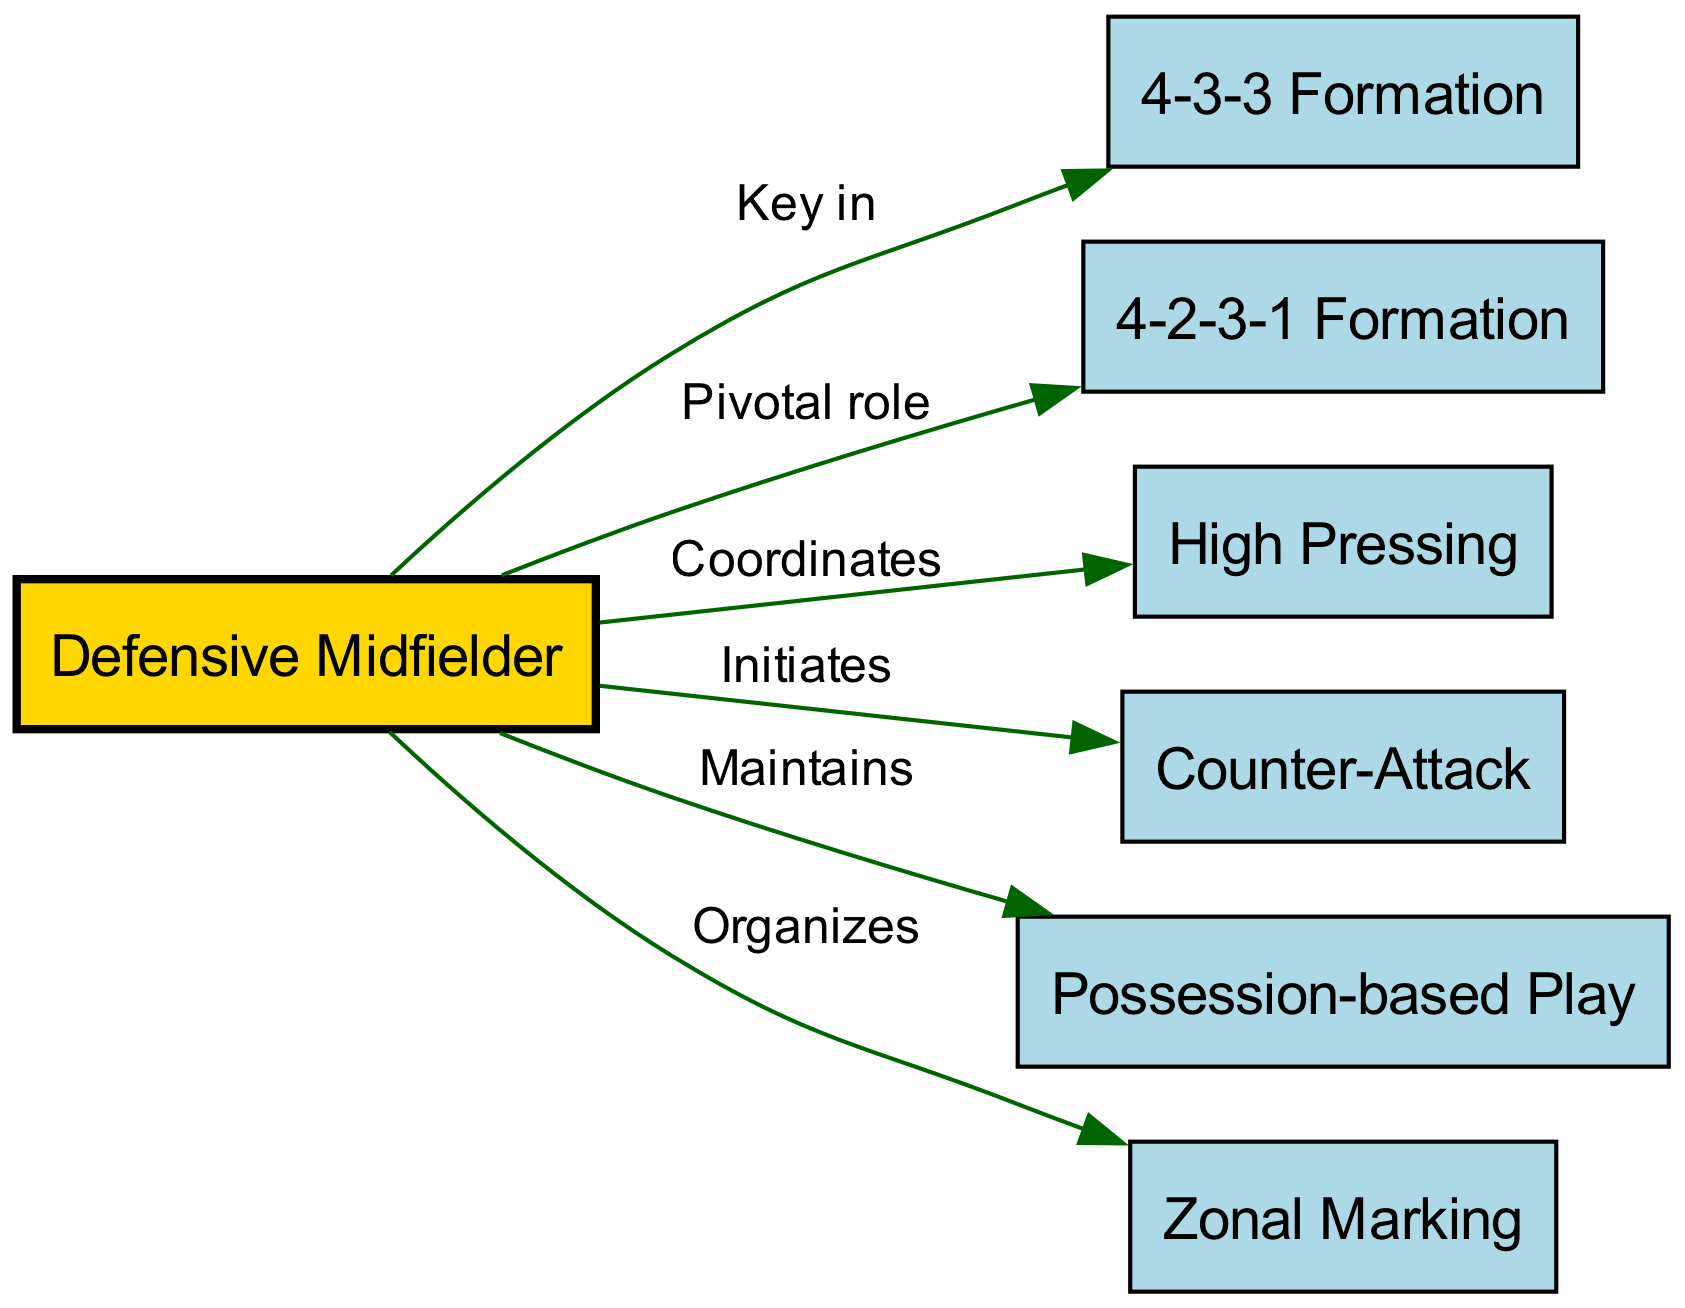what is the total number of nodes in the diagram? There are six nodes shown in the diagram: '4-3-3 Formation', '4-2-3-1 Formation', 'Defensive Midfielder', 'High Pressing', 'Counter-Attack', and 'Possession-based Play'.
Answer: 6 which formation is a key role for the defensive midfielder? The diagram indicates two formations connected to the defensive midfielder: '4-3-3 Formation' (Key in) and '4-2-3-1 Formation' (Pivotal role). However, the direct designation is for the '4-3-3 Formation' where it says "Key in".
Answer: 4-3-3 Formation how many edges connect to the defensive midfielder? The diagram shows five edges connecting to the 'Defensive Midfielder', linking it to four different tactical play styles: 'High Pressing', 'Counter-Attack', 'Possession-based Play', and 'Zonal Marking'.
Answer: 5 what does the defensive midfielder maintain according to the diagram? The edge labeled 'Maintains' leads from the 'Defensive Midfielder' to 'Possession-based Play', indicating that this is a responsibility of the defensive midfielder.
Answer: Possession-based Play which tactical approach does the defensive midfielder initiate? The diagram shows an edge labeled 'Initiates' from the 'Defensive Midfielder' to 'Counter-Attack', indicating that initiating counter-attacks is a role associated with the defensive midfielder.
Answer: Counter-Attack what role does the defensive midfielder play in zonal marking? The connection labeled 'Organizes' from the 'Defensive Midfielder' to 'Zonal Marking' suggests that the defensive midfielder's role includes organizing zonal marking during play.
Answer: Organizes how does the defensive midfielder contribute to high pressing? According to the diagram, the relationship labeled 'Coordinates' indicates that the defensive midfielder coordinates the high pressing as part of the team's tactical execution.
Answer: Coordinates what type of diagram is depicted here? The diagram is a concept map that outlines the relationships between different tactical formations and player roles in modern soccer, specifically focusing on the defensive midfielder's contributions.
Answer: Concept map 